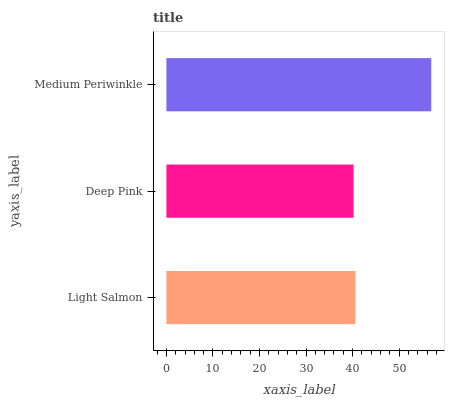Is Deep Pink the minimum?
Answer yes or no. Yes. Is Medium Periwinkle the maximum?
Answer yes or no. Yes. Is Medium Periwinkle the minimum?
Answer yes or no. No. Is Deep Pink the maximum?
Answer yes or no. No. Is Medium Periwinkle greater than Deep Pink?
Answer yes or no. Yes. Is Deep Pink less than Medium Periwinkle?
Answer yes or no. Yes. Is Deep Pink greater than Medium Periwinkle?
Answer yes or no. No. Is Medium Periwinkle less than Deep Pink?
Answer yes or no. No. Is Light Salmon the high median?
Answer yes or no. Yes. Is Light Salmon the low median?
Answer yes or no. Yes. Is Medium Periwinkle the high median?
Answer yes or no. No. Is Medium Periwinkle the low median?
Answer yes or no. No. 